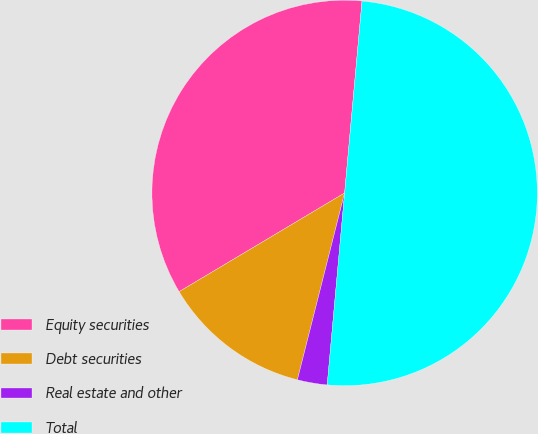<chart> <loc_0><loc_0><loc_500><loc_500><pie_chart><fcel>Equity securities<fcel>Debt securities<fcel>Real estate and other<fcel>Total<nl><fcel>35.0%<fcel>12.5%<fcel>2.5%<fcel>50.0%<nl></chart> 